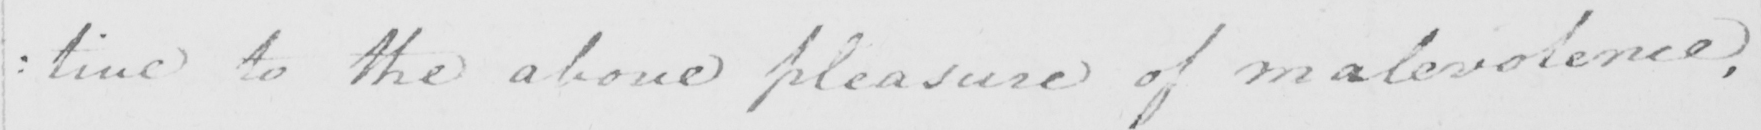Please provide the text content of this handwritten line. : tive to the above pleasure of malevolence , 